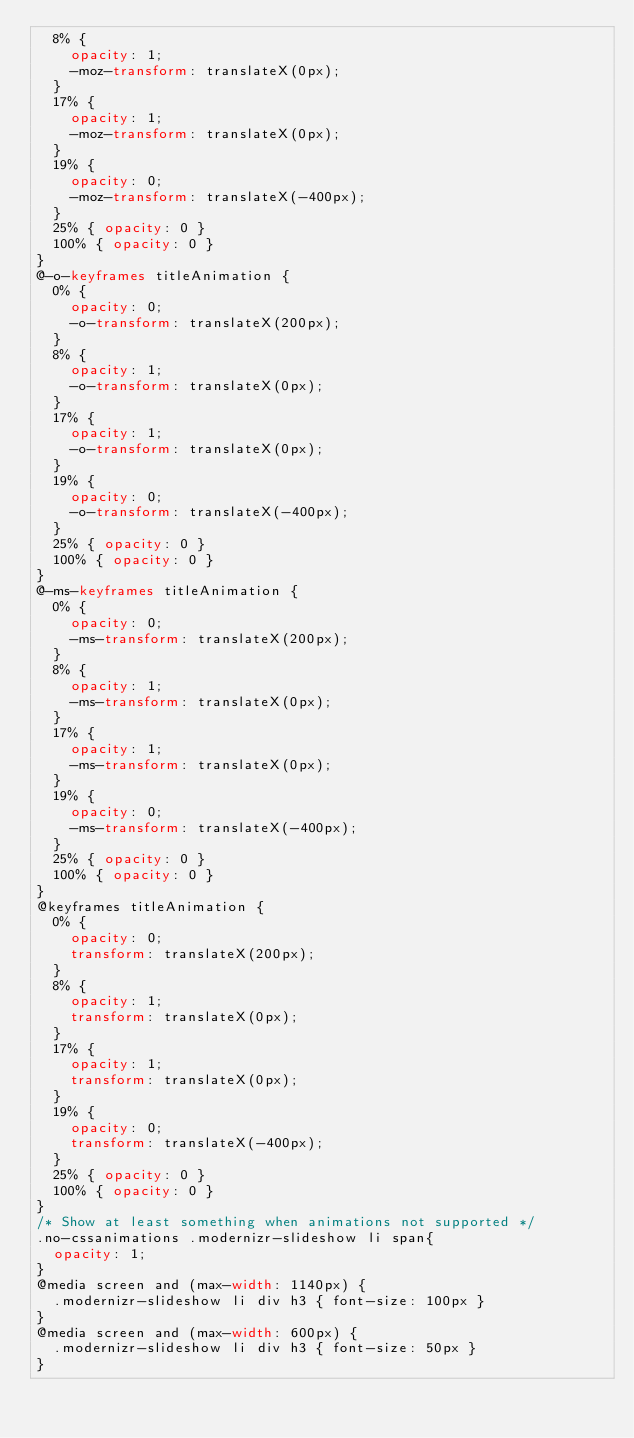Convert code to text. <code><loc_0><loc_0><loc_500><loc_500><_CSS_>  8% {
    opacity: 1;
    -moz-transform: translateX(0px);
  }
  17% {
    opacity: 1;
    -moz-transform: translateX(0px);
  }
  19% {
    opacity: 0;
    -moz-transform: translateX(-400px);
  }
  25% { opacity: 0 }
  100% { opacity: 0 }
}
@-o-keyframes titleAnimation { 
  0% {
    opacity: 0;
    -o-transform: translateX(200px);
  }
  8% {
    opacity: 1;
    -o-transform: translateX(0px);
  }
  17% {
    opacity: 1;
    -o-transform: translateX(0px);
  }
  19% {
    opacity: 0;
    -o-transform: translateX(-400px);
  }
  25% { opacity: 0 }
  100% { opacity: 0 }
}
@-ms-keyframes titleAnimation { 
  0% {
    opacity: 0;
    -ms-transform: translateX(200px);
  }
  8% {
    opacity: 1;
    -ms-transform: translateX(0px);
  }
  17% {
    opacity: 1;
    -ms-transform: translateX(0px);
  }
  19% {
    opacity: 0;
    -ms-transform: translateX(-400px);
  }
  25% { opacity: 0 }
  100% { opacity: 0 }
}
@keyframes titleAnimation { 
  0% {
    opacity: 0;
    transform: translateX(200px);
  }
  8% {
    opacity: 1;
    transform: translateX(0px);
  }
  17% {
    opacity: 1;
    transform: translateX(0px);
  }
  19% {
    opacity: 0;
    transform: translateX(-400px);
  }
  25% { opacity: 0 }
  100% { opacity: 0 }
}
/* Show at least something when animations not supported */
.no-cssanimations .modernizr-slideshow li span{
  opacity: 1;
}
@media screen and (max-width: 1140px) { 
  .modernizr-slideshow li div h3 { font-size: 100px }
}
@media screen and (max-width: 600px) { 
  .modernizr-slideshow li div h3 { font-size: 50px }
}</code> 